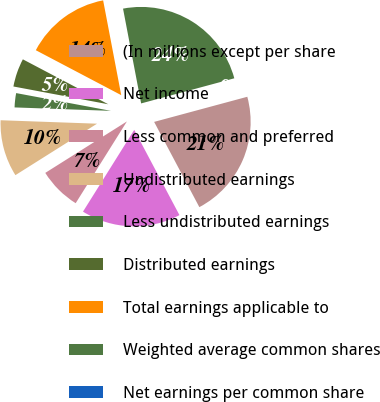Convert chart to OTSL. <chart><loc_0><loc_0><loc_500><loc_500><pie_chart><fcel>(In millions except per share<fcel>Net income<fcel>Less common and preferred<fcel>Undistributed earnings<fcel>Less undistributed earnings<fcel>Distributed earnings<fcel>Total earnings applicable to<fcel>Weighted average common shares<fcel>Net earnings per common share<nl><fcel>21.43%<fcel>16.67%<fcel>7.14%<fcel>9.52%<fcel>2.38%<fcel>4.76%<fcel>14.29%<fcel>23.81%<fcel>0.0%<nl></chart> 